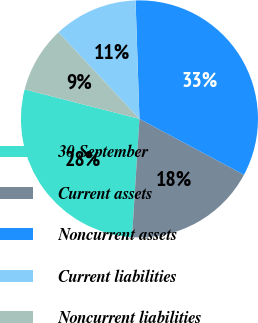Convert chart to OTSL. <chart><loc_0><loc_0><loc_500><loc_500><pie_chart><fcel>30 September<fcel>Current assets<fcel>Noncurrent assets<fcel>Current liabilities<fcel>Noncurrent liabilities<nl><fcel>28.0%<fcel>18.19%<fcel>33.33%<fcel>11.45%<fcel>9.02%<nl></chart> 